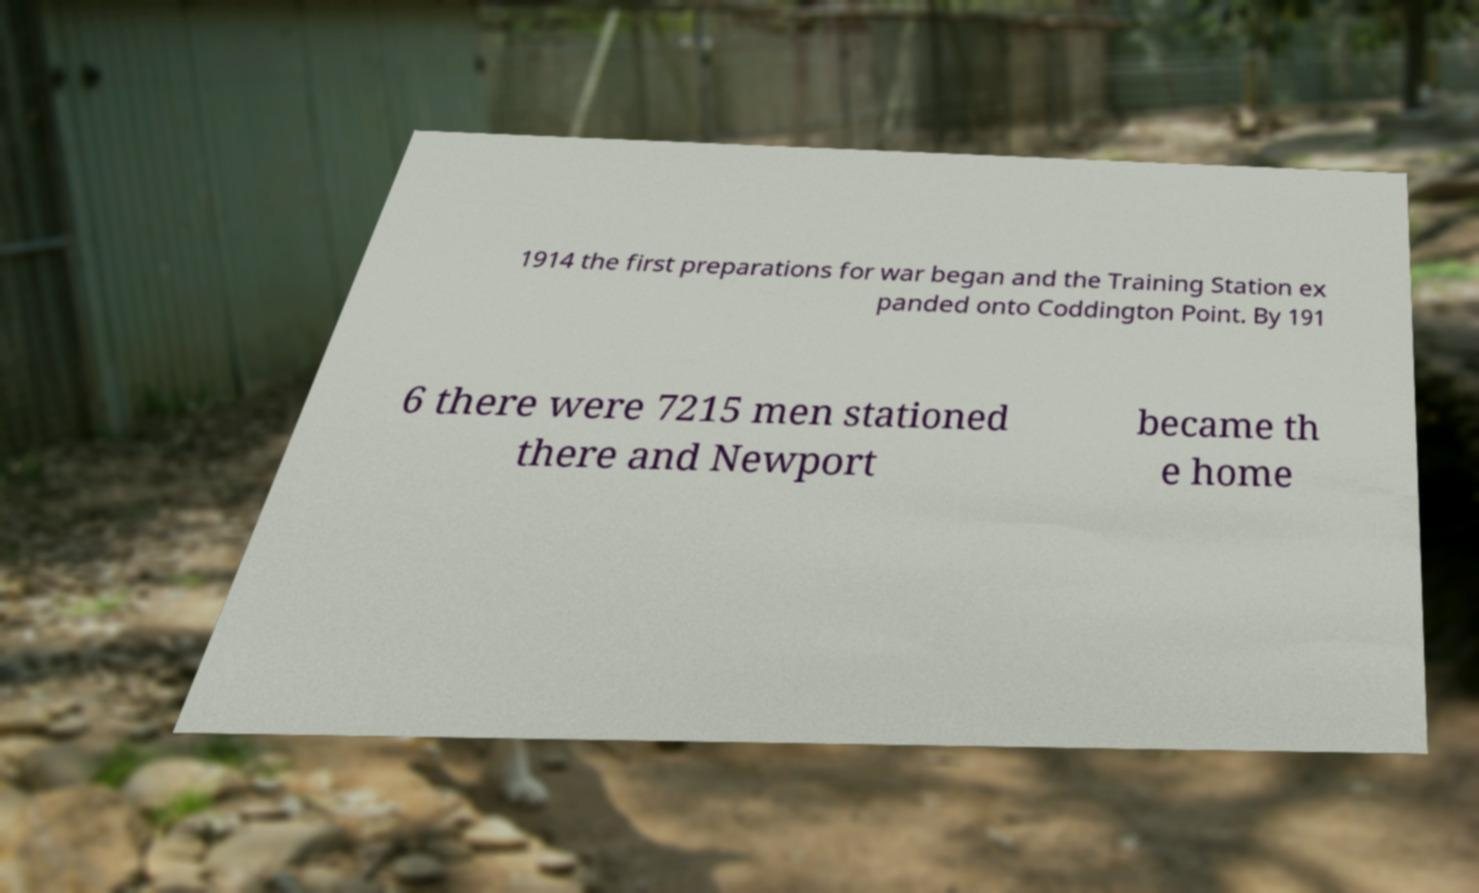For documentation purposes, I need the text within this image transcribed. Could you provide that? 1914 the first preparations for war began and the Training Station ex panded onto Coddington Point. By 191 6 there were 7215 men stationed there and Newport became th e home 